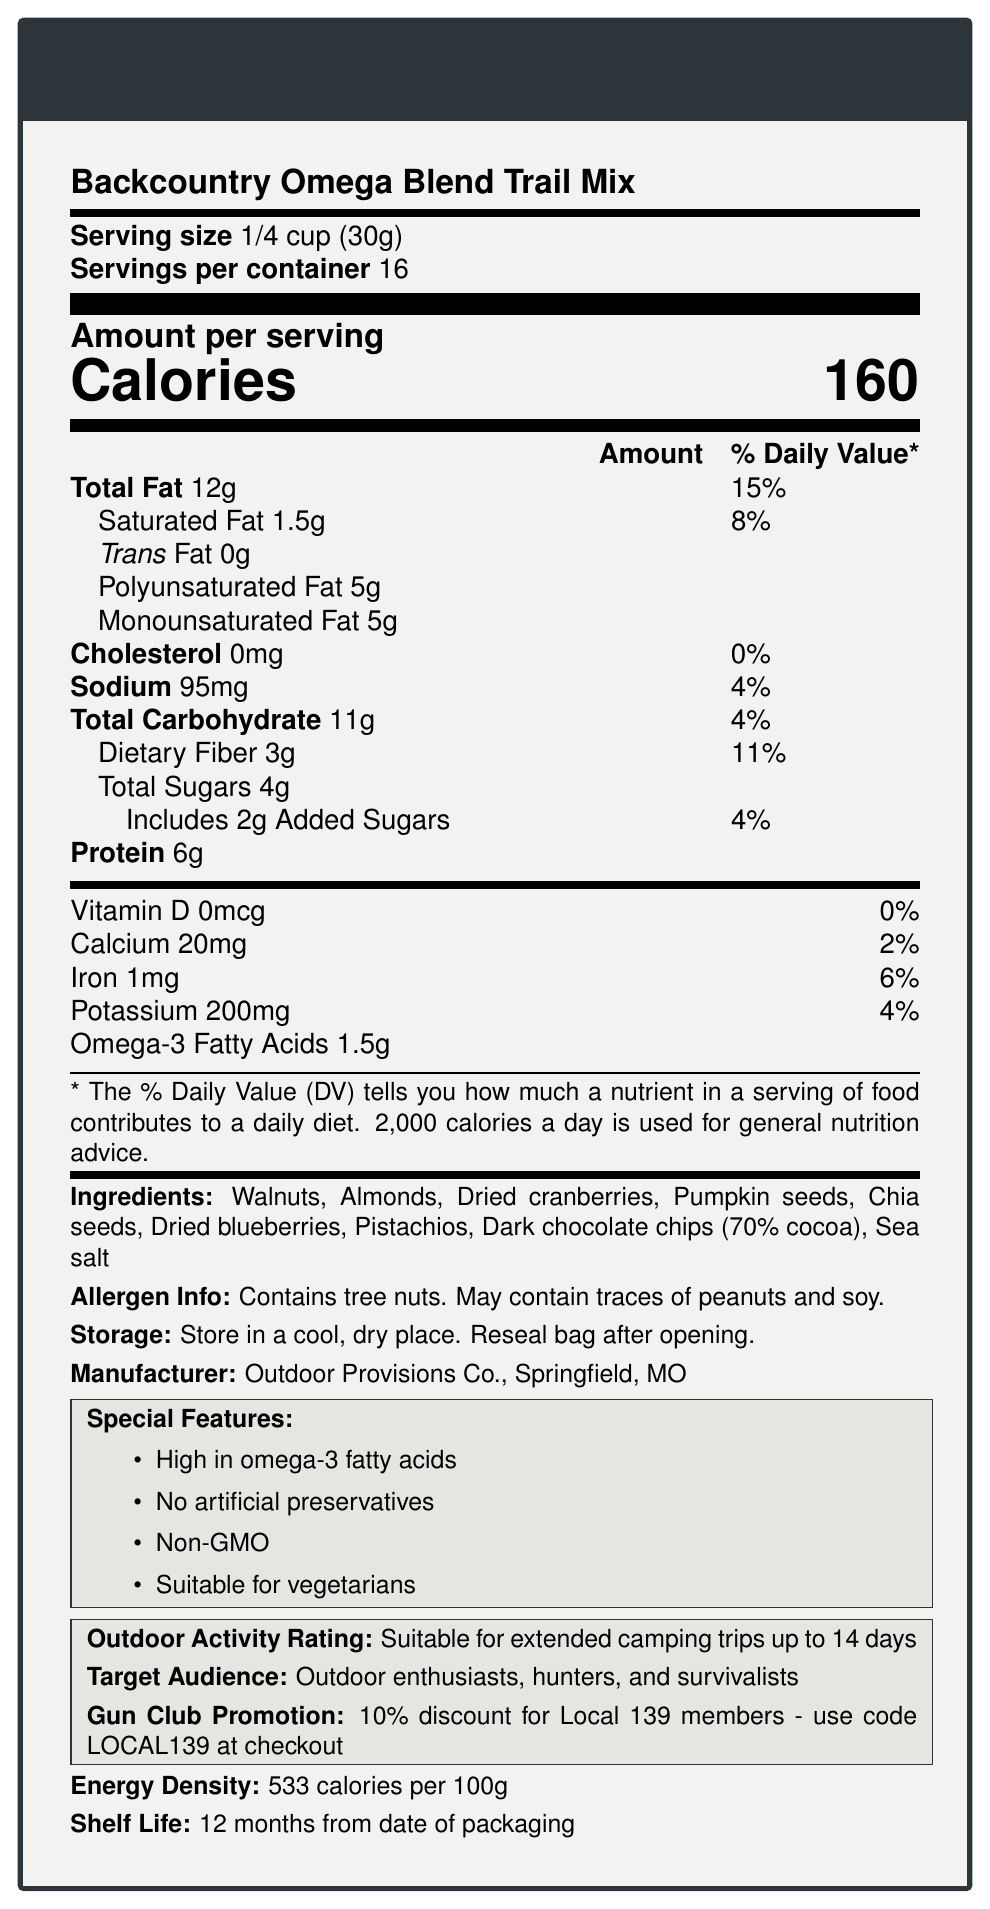what is the serving size? The serving size is explicitly stated as 1/4 cup (30g) in the document.
Answer: 1/4 cup (30g) how many calories are there per serving? The document specifies that there are 160 calories per serving.
Answer: 160 how many servings are there per container? The document mentions that there are 16 servings per container.
Answer: 16 what is the total fat content per serving? The document indicates that the total fat content per serving is 12g.
Answer: 12g how many grams of dietary fiber are in one serving? The document specifies that each serving contains 3 grams of dietary fiber.
Answer: 3g does the product have any trans fat? The document indicates that the trans fat content is 0g, which means it does not have any trans fat.
Answer: No what ingredients are present in the trail mix? The document lists these ingredients as part of the trail mix.
Answer: Walnuts, Almonds, Dried cranberries, Pumpkin seeds, Chia seeds, Dried blueberries, Pistachios, Dark chocolate chips (70% cocoa), Sea salt what is the total carbohydrate content per serving? The document states that each serving contains 11 grams of total carbohydrates.
Answer: 11g is this product suitable for vegetarians? The document explicitly states that the product is suitable for vegetarians.
Answer: Yes are any artificial preservatives included in this product? The document mentions as a special feature that the product contains no artificial preservatives.
Answer: No the omega-3 content per serving is The document lists the omega-3 fatty acids content as 1.5g per serving.
Answer: 1.5g where is the manufacturer located? The document states that the manufacturer, Outdoor Provisions Co., is located in Springfield, MO.
Answer: Springfield, MO how much sodium is in a single serving? The document specifies that there is 95mg of sodium in a single serving.
Answer: 95mg what is the energy density of the product? The document states that the energy density is 533 calories per 100g.
Answer: 533 calories per 100g What is the shelf life of the product? The document mentions that the shelf life is 12 months from the date of packaging.
Answer: 12 months from date of packaging what is the special feature related to omega-3 fatty acids? A. Low in omega-3 fatty acids B. High in omega-3 fatty acids C. No omega-3 fatty acids The special features section of the document states that the product is high in omega-3 fatty acids.
Answer: B which of the following is not listed as an ingredient? I. Walnuts II. Almonds III. Peanuts IV. Dark chocolate chips The document lists Walnuts, Almonds, and Dark chocolate chips as ingredients but does not include Peanuts.
Answer: III. Peanuts is the product GMO-free? The special features section of the document mentions that the product is Non-GMO.
Answer: Yes what is the product's outdoor activity rating? The document states that the product is suitable for extended camping trips up to 14 days.
Answer: Suitable for extended camping trips up to 14 days does the document mention the total grams of sugar content? While the document states the total sugars (4g) and added sugars (2g), it does not specify the total grams of sugar combining both.
Answer: No summary description of the document The document provides comprehensive nutritional information, ingredient list, special features such as being high in omega-3 fatty acids and non-GMO, and other pertinent details for outdoor enthusiasts and survivalists.
Answer: The document is a nutrition facts label for "Backcountry Omega Blend Trail Mix," detailing serving size, calories, nutrient amounts and daily values, ingredients, allergen information, storage instructions, manufacturer details, special features, outdoor activity rating, target audience, promotion for Local 139 members, energy density, and shelf life. 